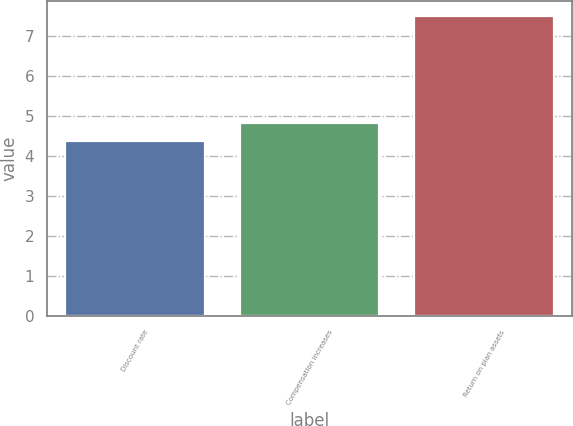Convert chart to OTSL. <chart><loc_0><loc_0><loc_500><loc_500><bar_chart><fcel>Discount rate<fcel>Compensation increases<fcel>Return on plan assets<nl><fcel>4.38<fcel>4.83<fcel>7.5<nl></chart> 